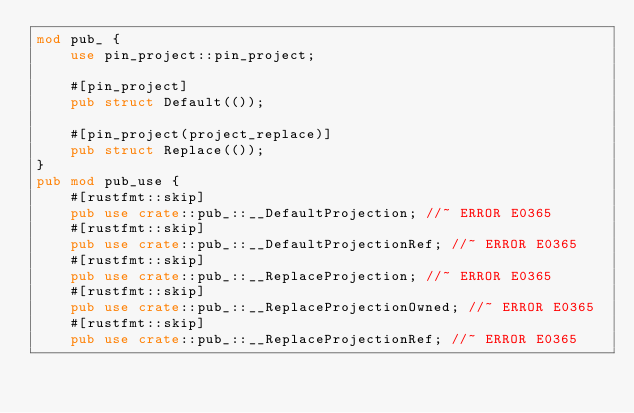Convert code to text. <code><loc_0><loc_0><loc_500><loc_500><_Rust_>mod pub_ {
    use pin_project::pin_project;

    #[pin_project]
    pub struct Default(());

    #[pin_project(project_replace)]
    pub struct Replace(());
}
pub mod pub_use {
    #[rustfmt::skip]
    pub use crate::pub_::__DefaultProjection; //~ ERROR E0365
    #[rustfmt::skip]
    pub use crate::pub_::__DefaultProjectionRef; //~ ERROR E0365
    #[rustfmt::skip]
    pub use crate::pub_::__ReplaceProjection; //~ ERROR E0365
    #[rustfmt::skip]
    pub use crate::pub_::__ReplaceProjectionOwned; //~ ERROR E0365
    #[rustfmt::skip]
    pub use crate::pub_::__ReplaceProjectionRef; //~ ERROR E0365
</code> 